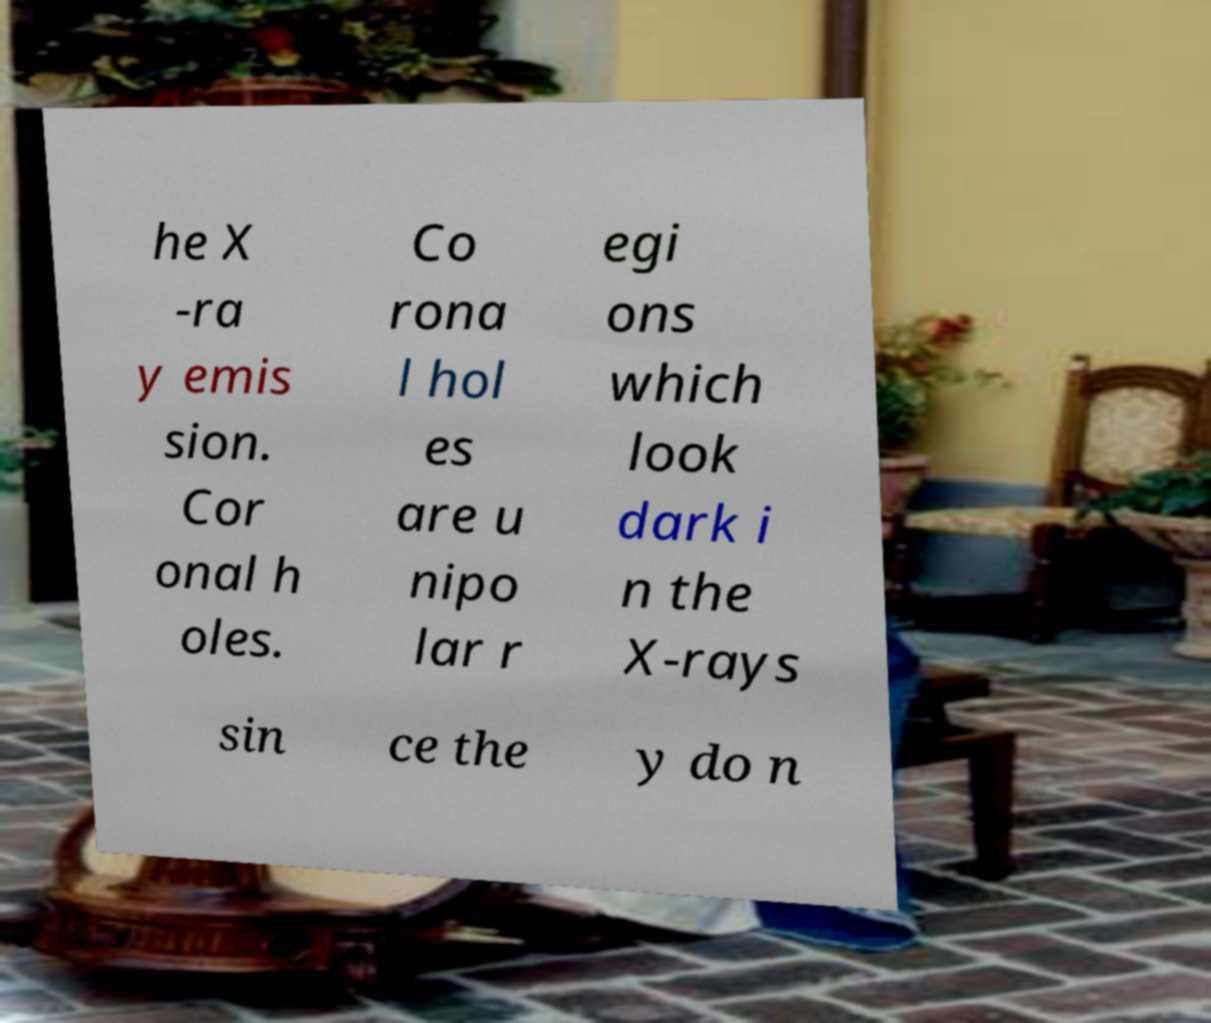What messages or text are displayed in this image? I need them in a readable, typed format. he X -ra y emis sion. Cor onal h oles. Co rona l hol es are u nipo lar r egi ons which look dark i n the X-rays sin ce the y do n 